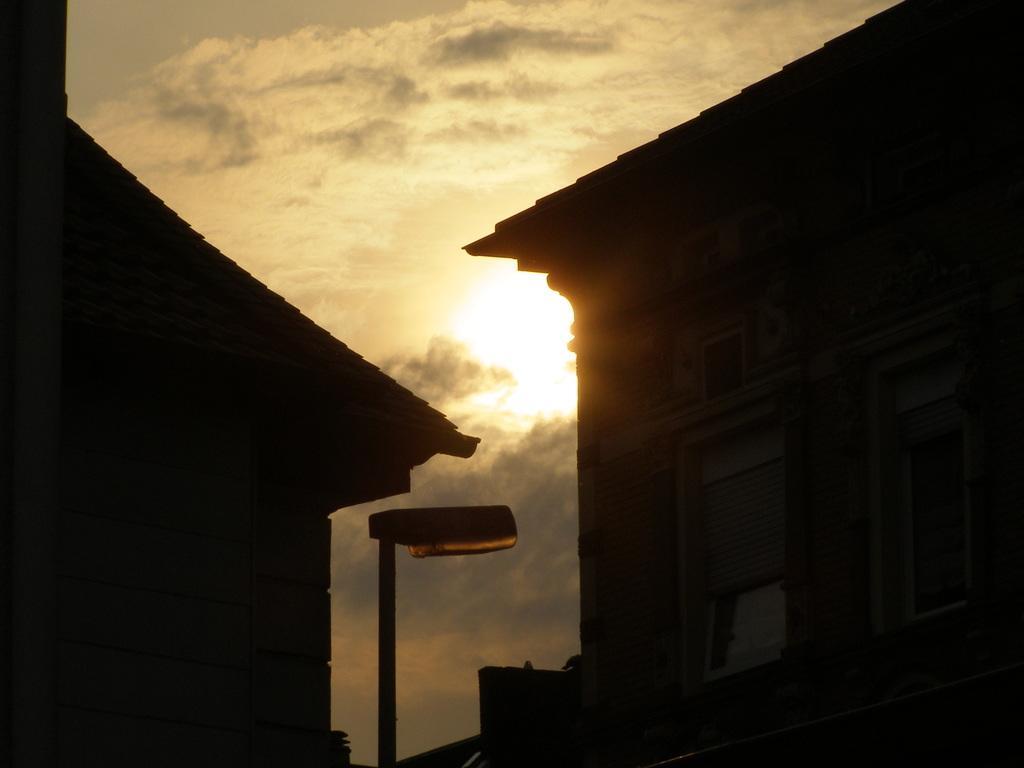In one or two sentences, can you explain what this image depicts? In this picture we can see there are buildings and a pole. Behind the buildings there is the cloudy sky. 